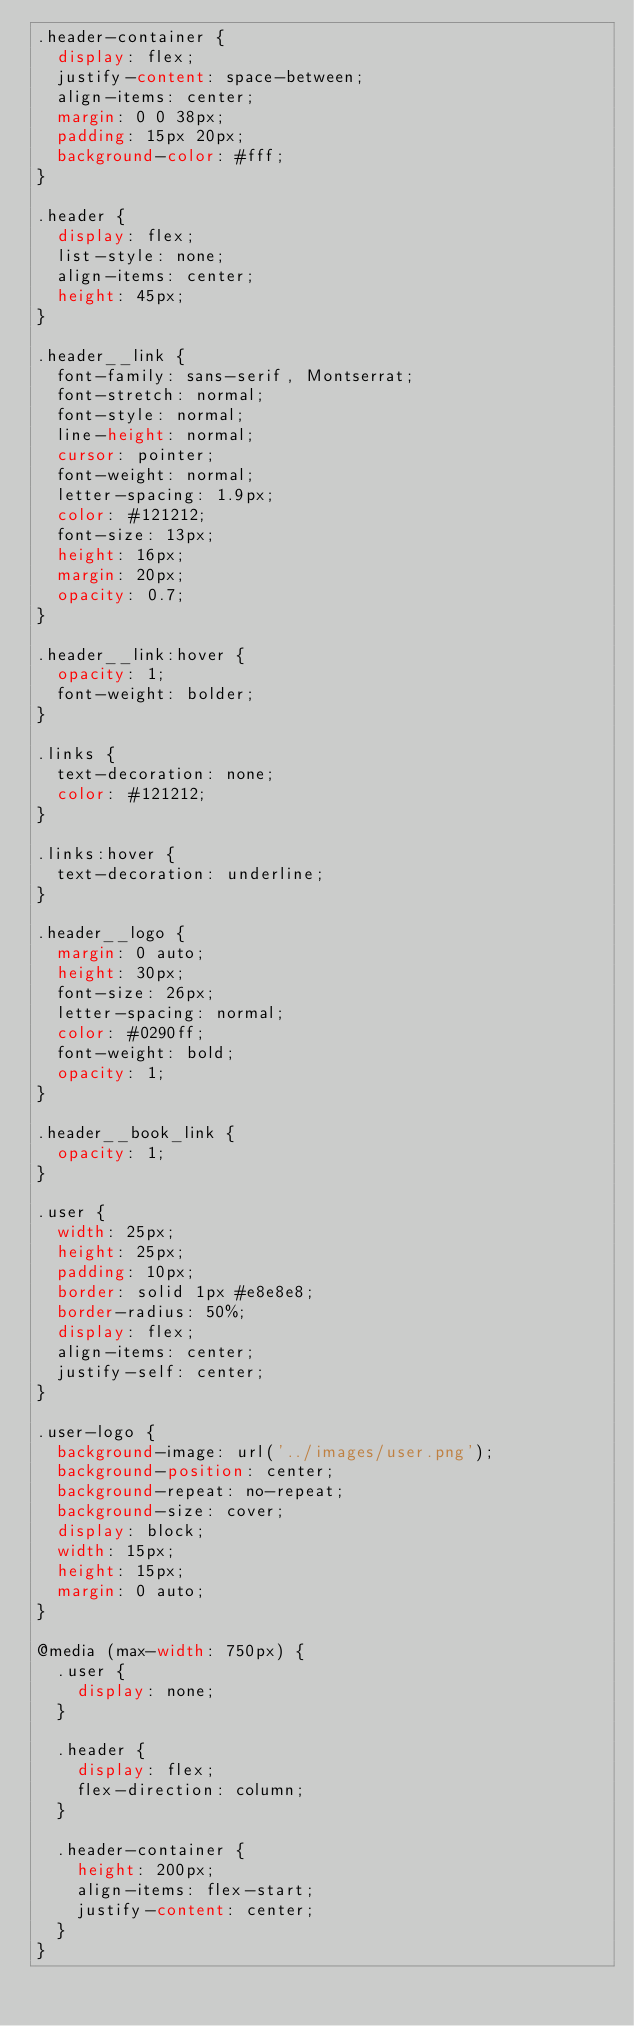<code> <loc_0><loc_0><loc_500><loc_500><_CSS_>.header-container {
  display: flex;
  justify-content: space-between;
  align-items: center;
  margin: 0 0 38px;
  padding: 15px 20px;
  background-color: #fff;
}

.header {
  display: flex;
  list-style: none;
  align-items: center;
  height: 45px;
}

.header__link {
  font-family: sans-serif, Montserrat;
  font-stretch: normal;
  font-style: normal;
  line-height: normal;
  cursor: pointer;
  font-weight: normal;
  letter-spacing: 1.9px;
  color: #121212;
  font-size: 13px;
  height: 16px;
  margin: 20px;
  opacity: 0.7;
}

.header__link:hover {
  opacity: 1;
  font-weight: bolder;
}

.links {
  text-decoration: none;
  color: #121212; 
}

.links:hover {
  text-decoration: underline;
}

.header__logo {
  margin: 0 auto;
  height: 30px;
  font-size: 26px;
  letter-spacing: normal;
  color: #0290ff;
  font-weight: bold;
  opacity: 1;
}

.header__book_link {
  opacity: 1;
}

.user {
  width: 25px;
  height: 25px;
  padding: 10px;
  border: solid 1px #e8e8e8;
  border-radius: 50%;
  display: flex;
  align-items: center;
  justify-self: center;
}

.user-logo {
  background-image: url('../images/user.png');
  background-position: center;
  background-repeat: no-repeat;
  background-size: cover;
  display: block;
  width: 15px;
  height: 15px;
  margin: 0 auto;
}

@media (max-width: 750px) {
  .user {
    display: none;
  }

  .header {
    display: flex;
    flex-direction: column;
  }

  .header-container {
    height: 200px;
    align-items: flex-start;
    justify-content: center;
  }
}
</code> 